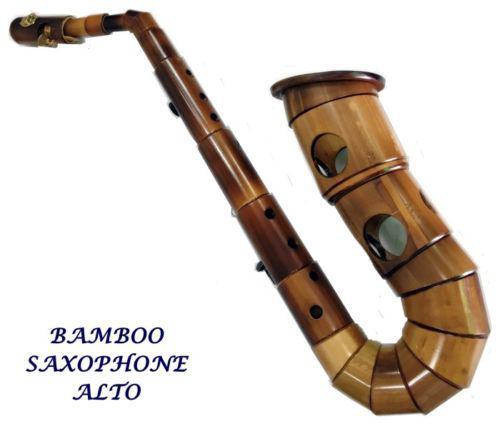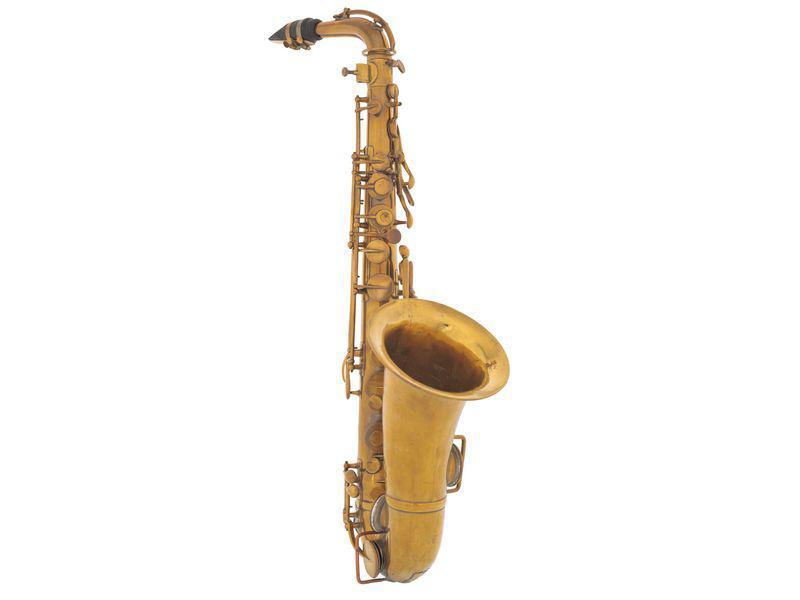The first image is the image on the left, the second image is the image on the right. Analyze the images presented: Is the assertion "The saxophones are standing against a white background" valid? Answer yes or no. Yes. 